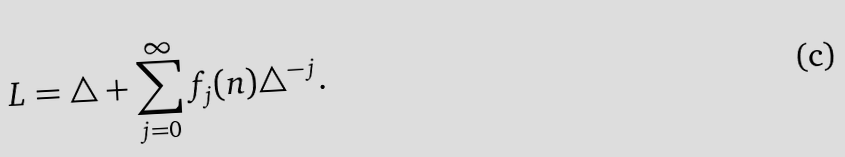Convert formula to latex. <formula><loc_0><loc_0><loc_500><loc_500>L = \triangle + \sum _ { j = 0 } ^ { \infty } f _ { j } ( n ) \triangle ^ { - j } .</formula> 